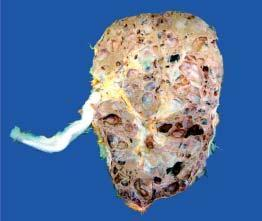what are not communicating with the pelvicalyceal system?
Answer the question using a single word or phrase. Cysts 